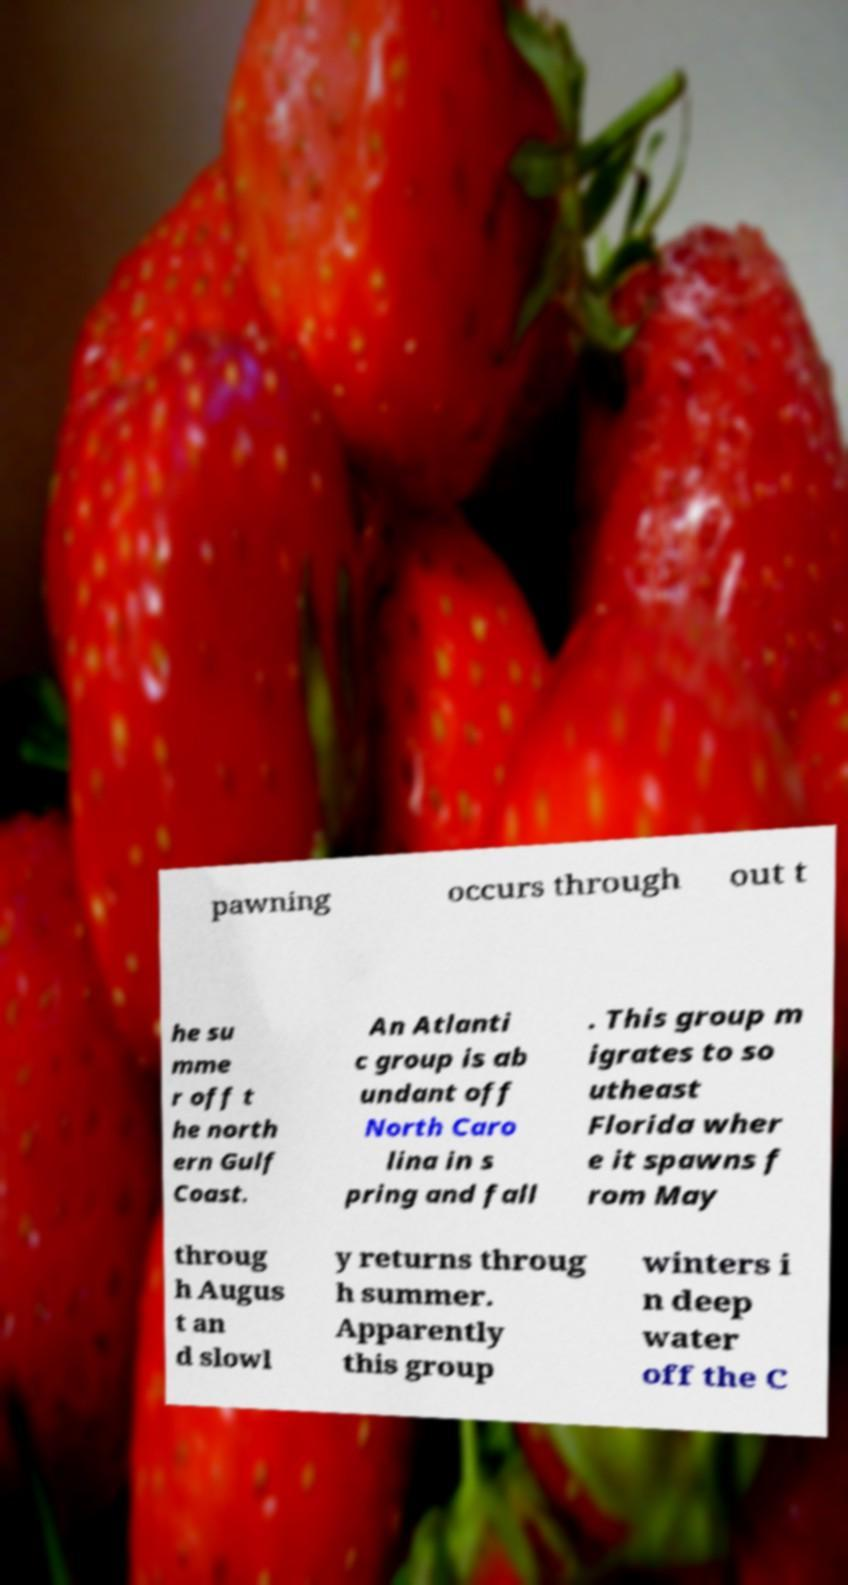Can you accurately transcribe the text from the provided image for me? pawning occurs through out t he su mme r off t he north ern Gulf Coast. An Atlanti c group is ab undant off North Caro lina in s pring and fall . This group m igrates to so utheast Florida wher e it spawns f rom May throug h Augus t an d slowl y returns throug h summer. Apparently this group winters i n deep water off the C 